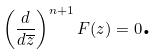Convert formula to latex. <formula><loc_0><loc_0><loc_500><loc_500>\left ( \frac { d } { d \overline { z } } \right ) ^ { n + 1 } F ( z ) = 0 \text {.}</formula> 